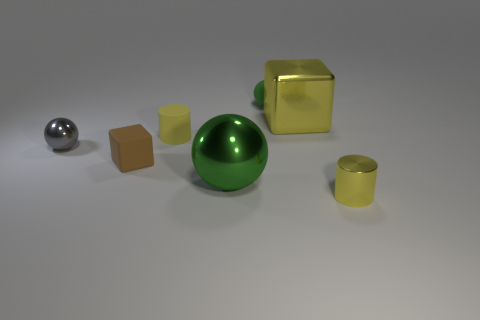How many yellow objects are matte spheres or small cylinders?
Your response must be concise. 2. The tiny matte cube is what color?
Ensure brevity in your answer.  Brown. There is a green thing that is the same material as the small gray ball; what is its size?
Offer a very short reply. Large. How many other big green objects have the same shape as the big green object?
Provide a short and direct response. 0. There is a shiny sphere on the right side of the yellow object to the left of the large yellow object; how big is it?
Give a very brief answer. Large. What material is the gray object that is the same size as the yellow matte cylinder?
Keep it short and to the point. Metal. Is there a cube that has the same material as the large sphere?
Your answer should be compact. Yes. What is the color of the large metal object that is in front of the yellow metallic thing behind the small shiny thing on the right side of the tiny green sphere?
Provide a succinct answer. Green. There is a cylinder left of the yellow shiny cylinder; is its color the same as the cube to the right of the tiny green rubber sphere?
Provide a succinct answer. Yes. Is there any other thing that is the same color as the small metallic sphere?
Give a very brief answer. No. 